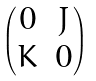<formula> <loc_0><loc_0><loc_500><loc_500>\begin{pmatrix} 0 & J \\ K & 0 \end{pmatrix}</formula> 